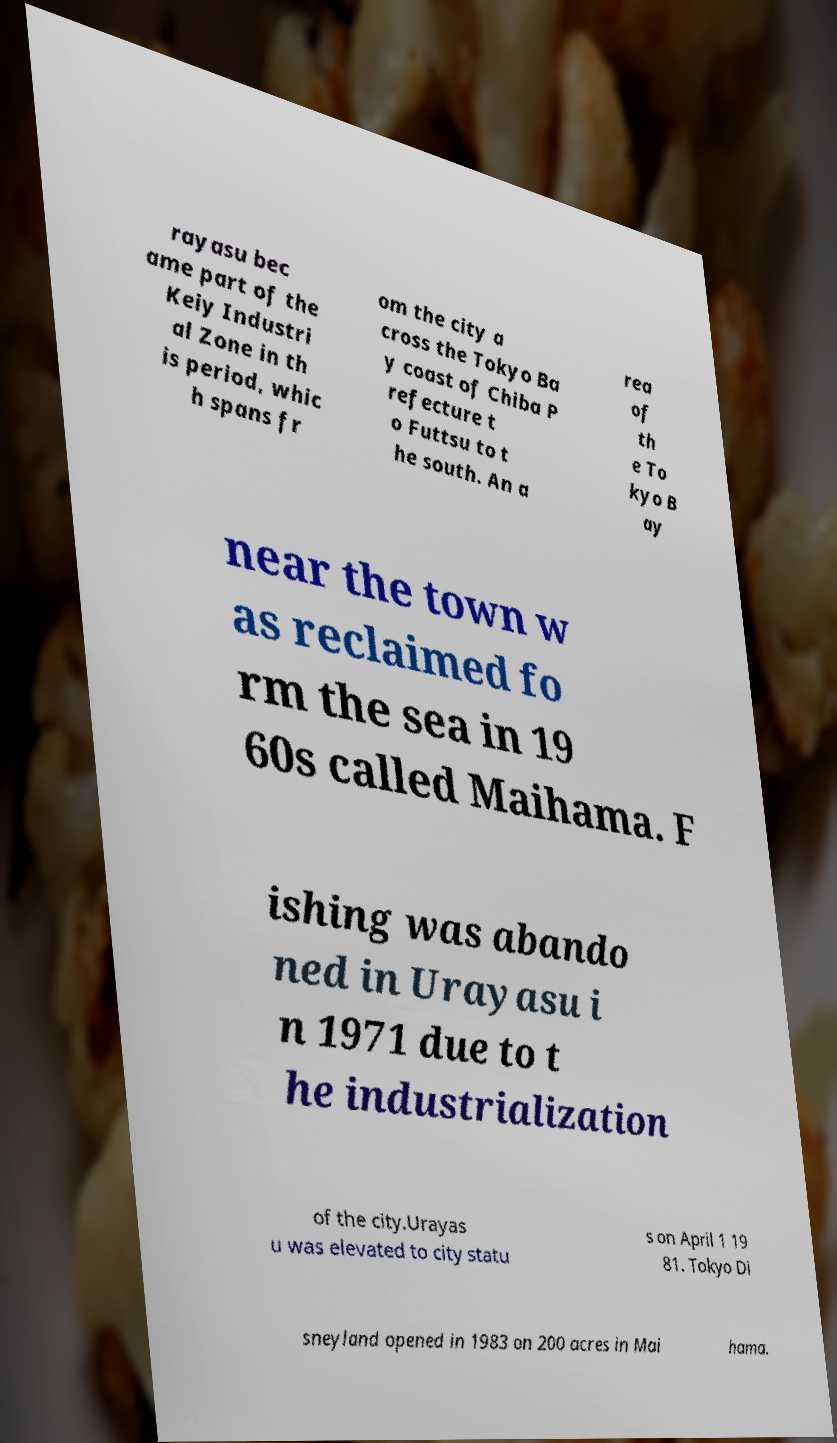Can you read and provide the text displayed in the image?This photo seems to have some interesting text. Can you extract and type it out for me? rayasu bec ame part of the Keiy Industri al Zone in th is period, whic h spans fr om the city a cross the Tokyo Ba y coast of Chiba P refecture t o Futtsu to t he south. An a rea of th e To kyo B ay near the town w as reclaimed fo rm the sea in 19 60s called Maihama. F ishing was abando ned in Urayasu i n 1971 due to t he industrialization of the city.Urayas u was elevated to city statu s on April 1 19 81. Tokyo Di sneyland opened in 1983 on 200 acres in Mai hama. 